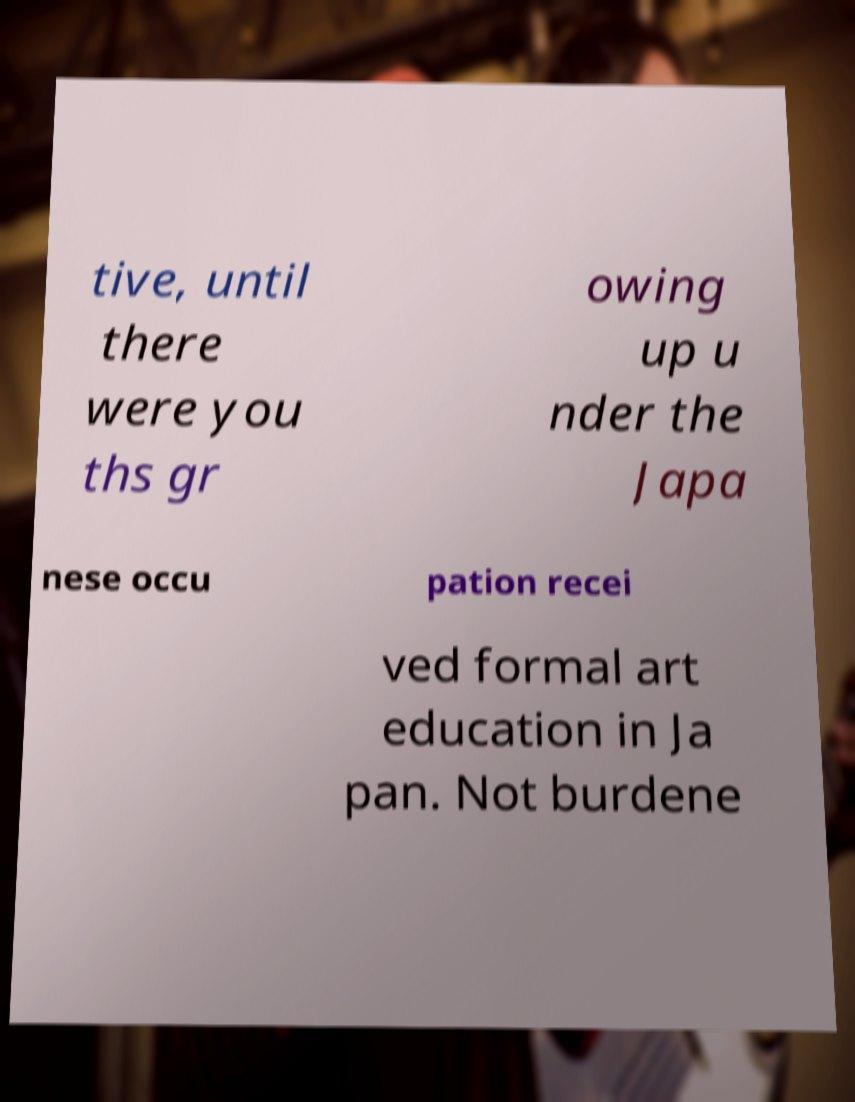There's text embedded in this image that I need extracted. Can you transcribe it verbatim? tive, until there were you ths gr owing up u nder the Japa nese occu pation recei ved formal art education in Ja pan. Not burdene 